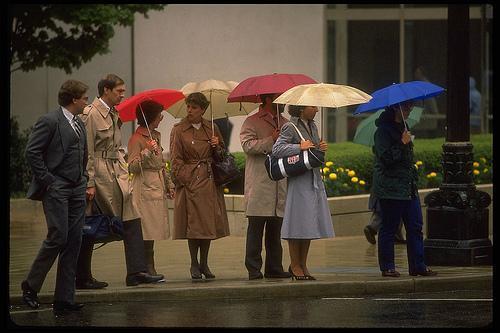How many umbrellas are there?
Give a very brief answer. 5. 